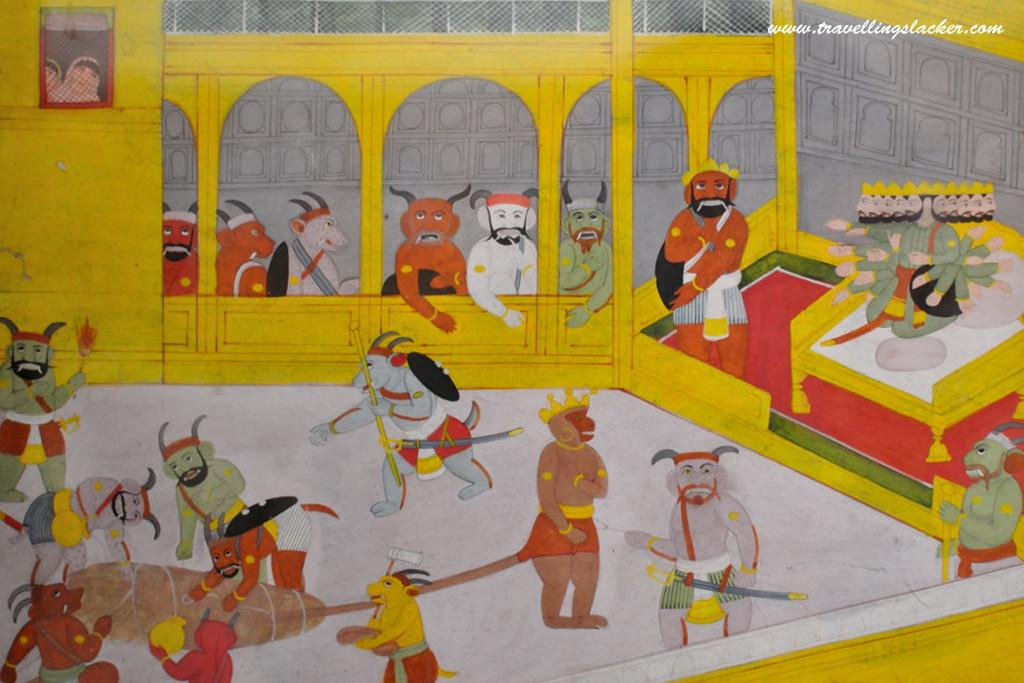What type of visual is the image? The image is a poster. What is happening in the poster? There is a group of people in the poster, and they are playing an act. What are the people holding in their hands? The people are holding objects in their hands. What can be seen in the background of the poster? There are windows visible in the background of the poster. What type of bell can be heard ringing in the image? There is no bell present in the image, and therefore no sound can be heard. Is there a tramp performing in the image? There is no mention of a tramp or any circus-related activities in the image. 